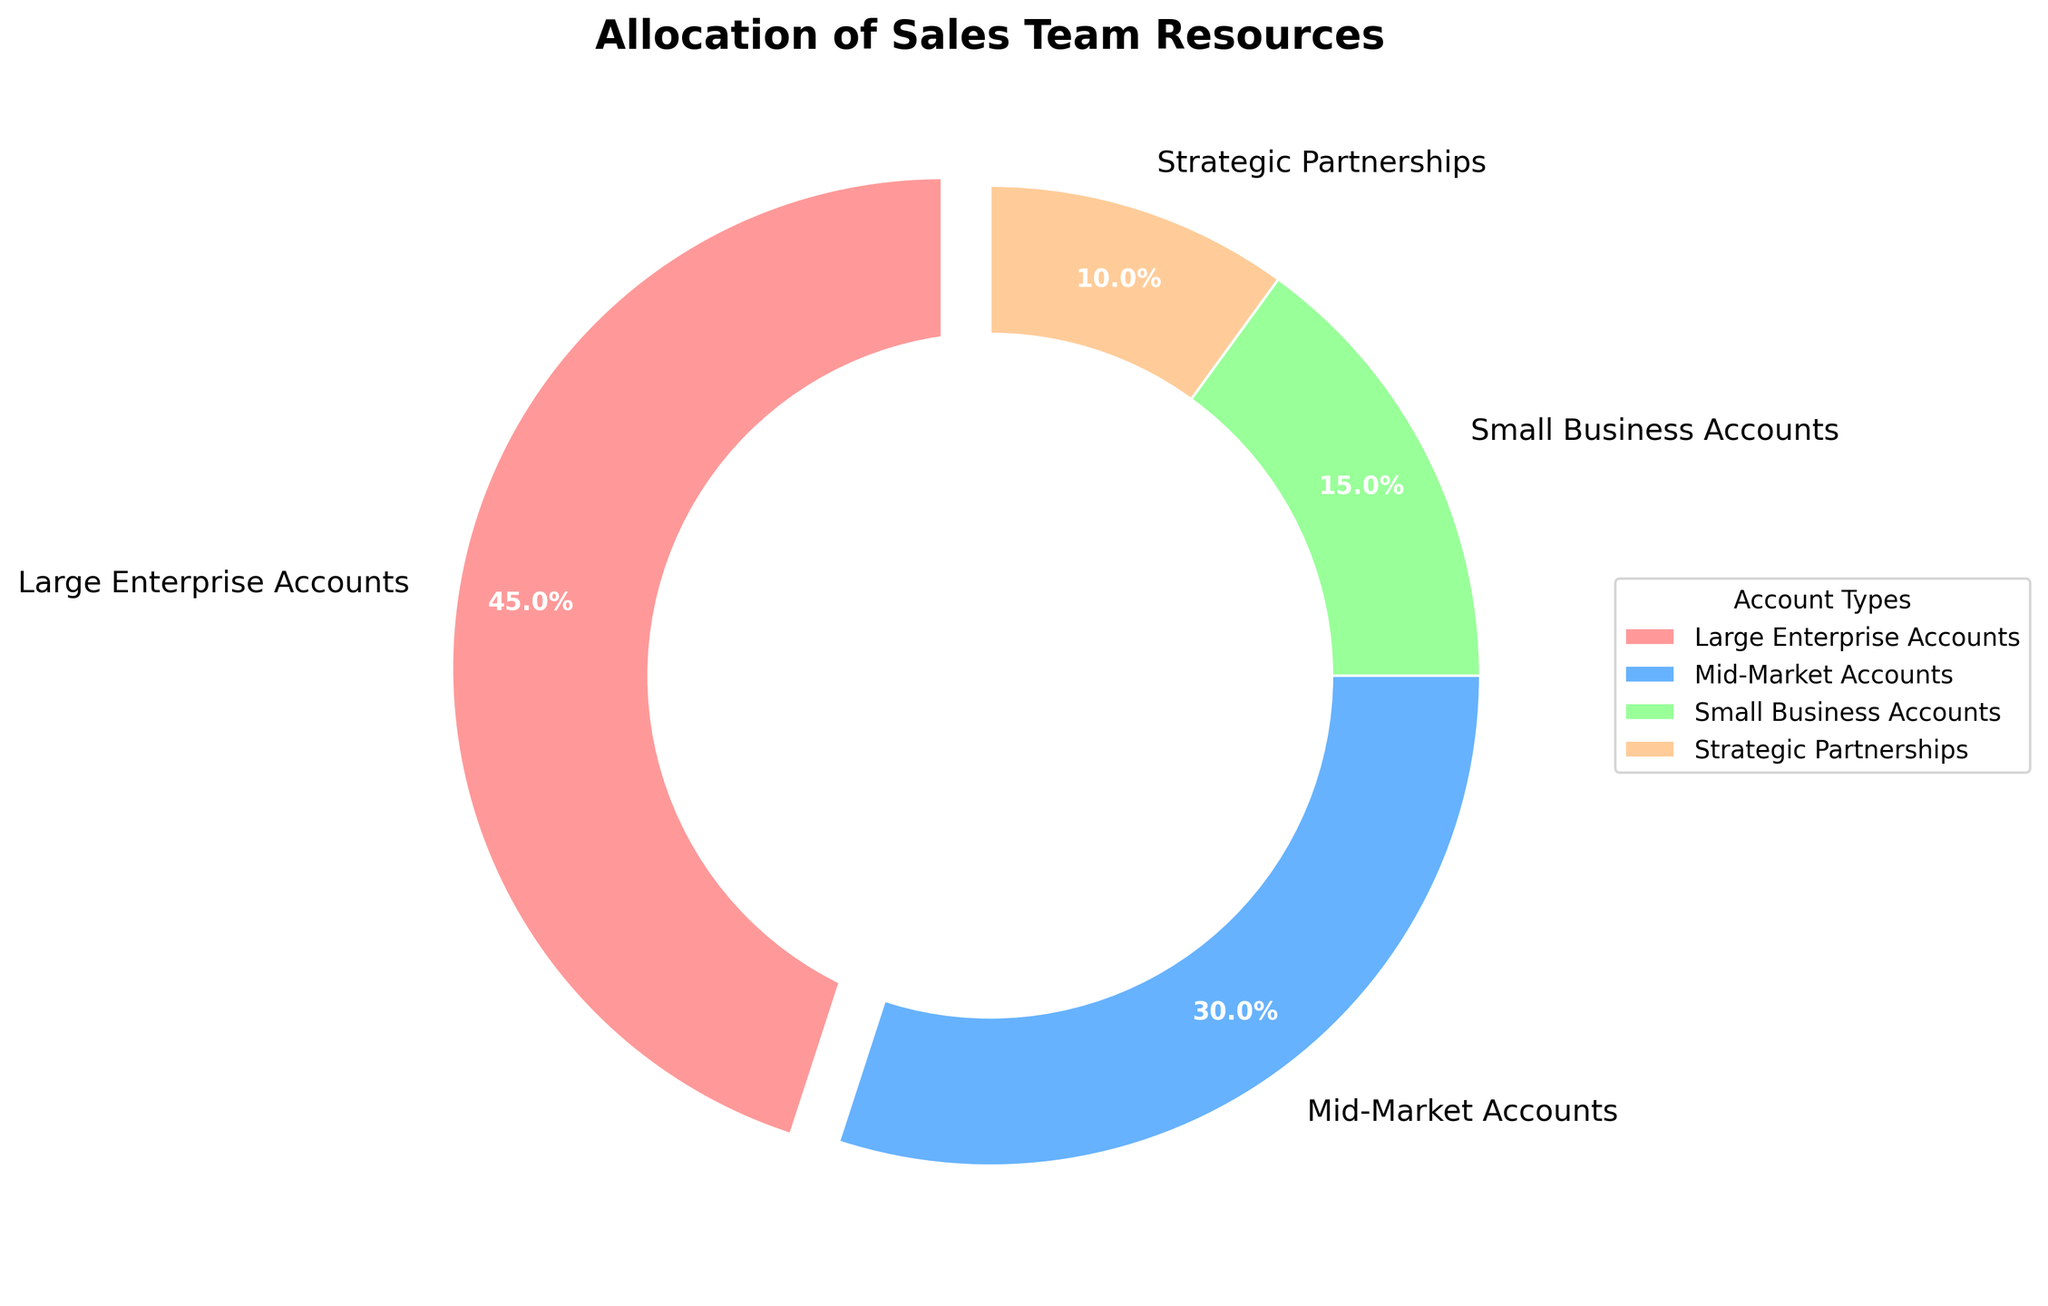What percentage of resources is allocated to Large Enterprise Accounts? The pie chart visually represents the allocation of resources to Large Enterprise Accounts as a segment that specifically references 45%.
Answer: 45% How much more in percentage is allocated to Mid-Market Accounts compared to Small Business Accounts? According to the pie chart, Mid-Market Accounts receive 30% of resources, while Small Business Accounts receive 15%. We subtract the percentage allocated to Small Business Accounts from that of Mid-Market Accounts. This results in 30% - 15% = 15%.
Answer: 15% Which category receives the least amount of resources? The pie chart displays the four categories with their respective percentages. The smallest percentage is 10%, which corresponds to Strategic Partnerships.
Answer: Strategic Partnerships What is the combined percentage of resources allocated to Small Business Accounts and Strategic Partnerships? The chart shows that Small Business Accounts are allocated 15% of resources and Strategic Partnerships are allocated 10%. Adding them together gives 15% + 10% = 25%.
Answer: 25% Which two categories combined receive more than half of the sales team resources? By observing the chart, Large Enterprise Accounts (45%) and Mid-Market Accounts (30%) are the largest segments. Combined, they account for 45% + 30% = 75%, which is more than half.
Answer: Large Enterprise Accounts and Mid-Market Accounts Which account type segment is highlighted or extruded? The visual pie chart shows that the slice representing Large Enterprise Accounts is slightly separated from the rest, often referred to as being exploded.
Answer: Large Enterprise Accounts Between Mid-Market Accounts and Large Enterprise Accounts, which one receives a greater percentage of resources? The pie chart's segments show that Large Enterprise Accounts receive 45% of resources compared to Mid-Market Accounts which receive 30%. Hence, Large Enterprise Accounts get a greater percentage.
Answer: Large Enterprise Accounts What is the total percentage of resources allocated to account types other than Large Enterprise Accounts? From the chart, the total resources for Mid-Market accounts (30%), Small Business Accounts (15%), and Strategic Partnerships (10%) must be summed up. Therefore, 30% + 15% + 10% = 55%.
Answer: 55% What color is the segment representing Strategic Partnerships? The pie chart uses various colors for different segments. The segment for Strategic Partnerships is represented in orange.
Answer: Orange 